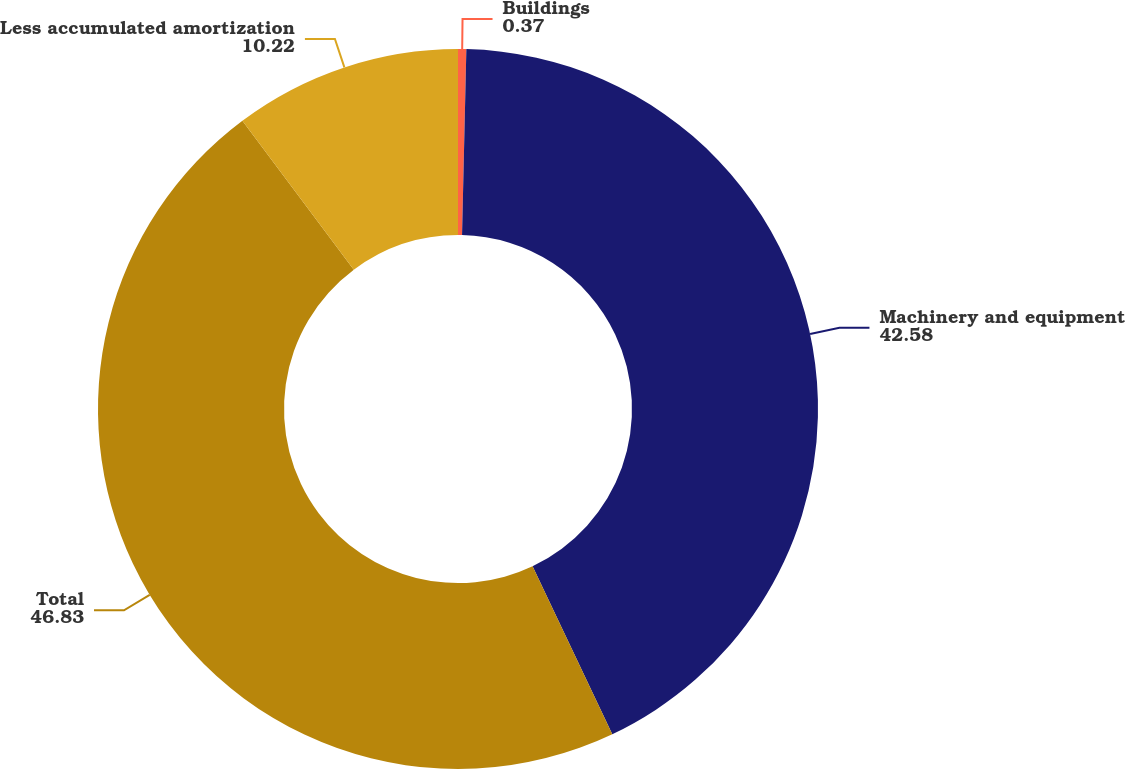Convert chart to OTSL. <chart><loc_0><loc_0><loc_500><loc_500><pie_chart><fcel>Buildings<fcel>Machinery and equipment<fcel>Total<fcel>Less accumulated amortization<nl><fcel>0.37%<fcel>42.58%<fcel>46.83%<fcel>10.22%<nl></chart> 